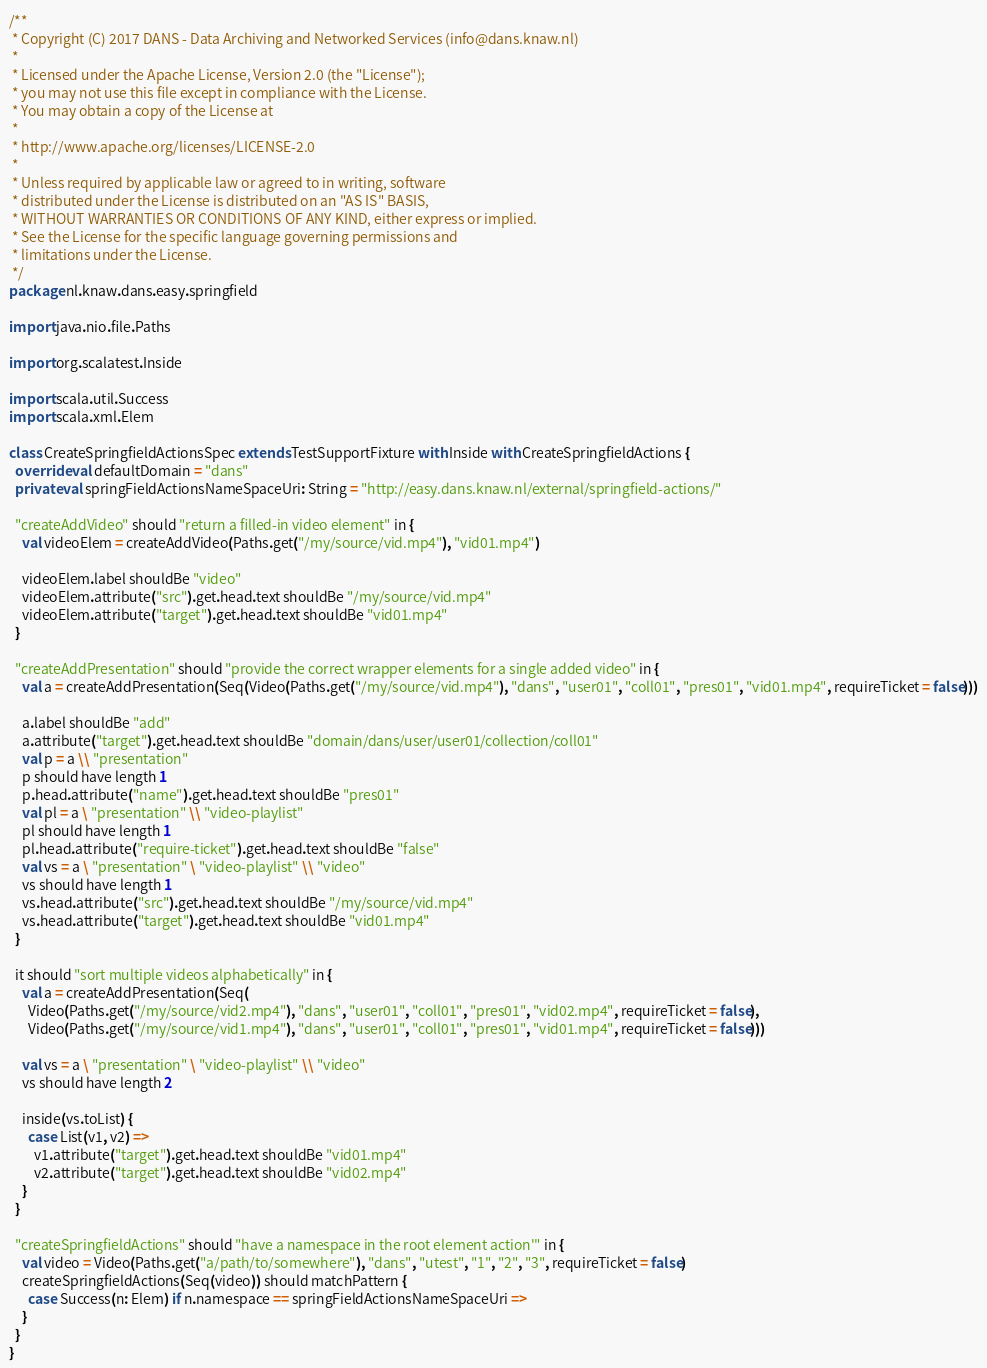Convert code to text. <code><loc_0><loc_0><loc_500><loc_500><_Scala_>/**
 * Copyright (C) 2017 DANS - Data Archiving and Networked Services (info@dans.knaw.nl)
 *
 * Licensed under the Apache License, Version 2.0 (the "License");
 * you may not use this file except in compliance with the License.
 * You may obtain a copy of the License at
 *
 * http://www.apache.org/licenses/LICENSE-2.0
 *
 * Unless required by applicable law or agreed to in writing, software
 * distributed under the License is distributed on an "AS IS" BASIS,
 * WITHOUT WARRANTIES OR CONDITIONS OF ANY KIND, either express or implied.
 * See the License for the specific language governing permissions and
 * limitations under the License.
 */
package nl.knaw.dans.easy.springfield

import java.nio.file.Paths

import org.scalatest.Inside

import scala.util.Success
import scala.xml.Elem

class CreateSpringfieldActionsSpec extends TestSupportFixture with Inside with CreateSpringfieldActions {
  override val defaultDomain = "dans"
  private val springFieldActionsNameSpaceUri: String = "http://easy.dans.knaw.nl/external/springfield-actions/"

  "createAddVideo" should "return a filled-in video element" in {
    val videoElem = createAddVideo(Paths.get("/my/source/vid.mp4"), "vid01.mp4")

    videoElem.label shouldBe "video"
    videoElem.attribute("src").get.head.text shouldBe "/my/source/vid.mp4"
    videoElem.attribute("target").get.head.text shouldBe "vid01.mp4"
  }

  "createAddPresentation" should "provide the correct wrapper elements for a single added video" in {
    val a = createAddPresentation(Seq(Video(Paths.get("/my/source/vid.mp4"), "dans", "user01", "coll01", "pres01", "vid01.mp4", requireTicket = false)))

    a.label shouldBe "add"
    a.attribute("target").get.head.text shouldBe "domain/dans/user/user01/collection/coll01"
    val p = a \\ "presentation"
    p should have length 1
    p.head.attribute("name").get.head.text shouldBe "pres01"
    val pl = a \ "presentation" \\ "video-playlist"
    pl should have length 1
    pl.head.attribute("require-ticket").get.head.text shouldBe "false"
    val vs = a \ "presentation" \ "video-playlist" \\ "video"
    vs should have length 1
    vs.head.attribute("src").get.head.text shouldBe "/my/source/vid.mp4"
    vs.head.attribute("target").get.head.text shouldBe "vid01.mp4"
  }

  it should "sort multiple videos alphabetically" in {
    val a = createAddPresentation(Seq(
      Video(Paths.get("/my/source/vid2.mp4"), "dans", "user01", "coll01", "pres01", "vid02.mp4", requireTicket = false),
      Video(Paths.get("/my/source/vid1.mp4"), "dans", "user01", "coll01", "pres01", "vid01.mp4", requireTicket = false)))

    val vs = a \ "presentation" \ "video-playlist" \\ "video"
    vs should have length 2

    inside(vs.toList) {
      case List(v1, v2) =>
        v1.attribute("target").get.head.text shouldBe "vid01.mp4"
        v2.attribute("target").get.head.text shouldBe "vid02.mp4"
    }
  }

  "createSpringfieldActions" should "have a namespace in the root element action'" in {
    val video = Video(Paths.get("a/path/to/somewhere"), "dans", "utest", "1", "2", "3", requireTicket = false)
    createSpringfieldActions(Seq(video)) should matchPattern {
      case Success(n: Elem) if n.namespace == springFieldActionsNameSpaceUri =>
    }
  }
}
</code> 